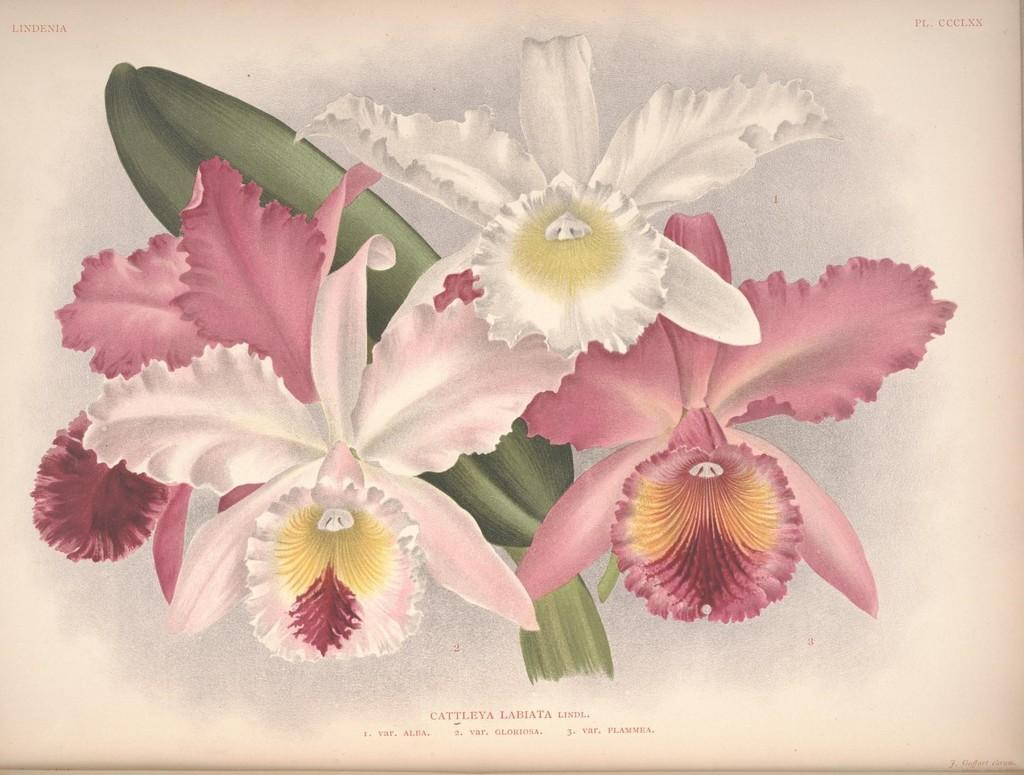What is depicted on the paper in the image? There is an art piece on the paper. Is there any text on the paper? Yes, there is writing on the paper. How many matches are used in the art piece on the paper? There are no matches present in the image; it features an art piece and writing on a paper. What type of cattle can be seen in the image? There are no cattle present in the image; it features an art piece and writing on a paper. 